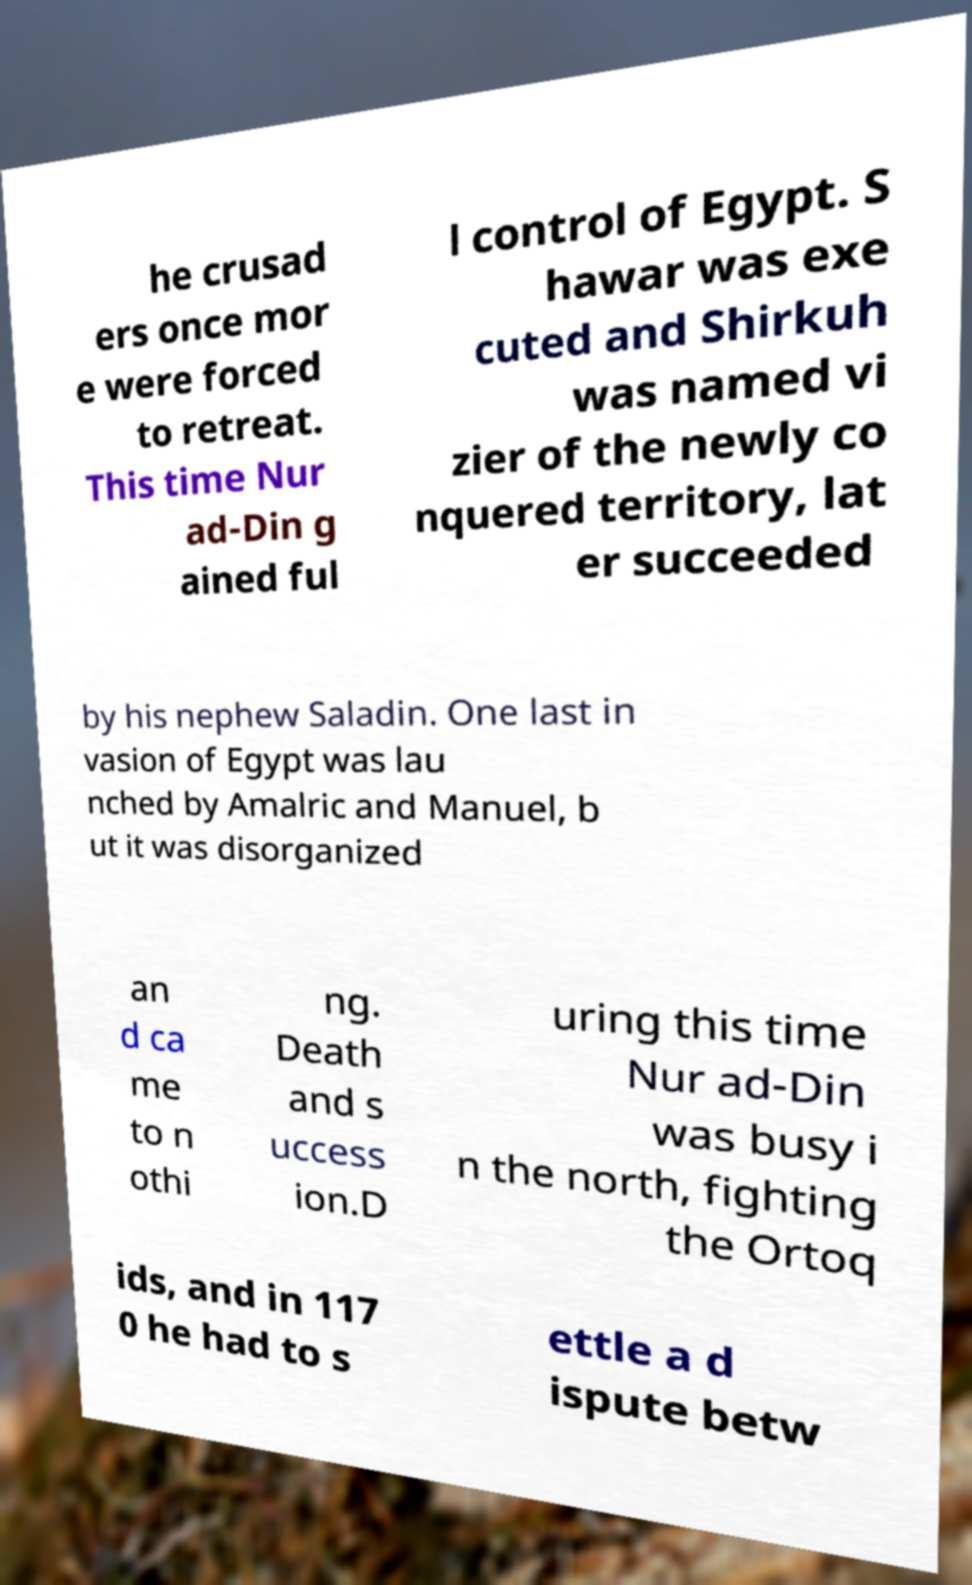For documentation purposes, I need the text within this image transcribed. Could you provide that? he crusad ers once mor e were forced to retreat. This time Nur ad-Din g ained ful l control of Egypt. S hawar was exe cuted and Shirkuh was named vi zier of the newly co nquered territory, lat er succeeded by his nephew Saladin. One last in vasion of Egypt was lau nched by Amalric and Manuel, b ut it was disorganized an d ca me to n othi ng. Death and s uccess ion.D uring this time Nur ad-Din was busy i n the north, fighting the Ortoq ids, and in 117 0 he had to s ettle a d ispute betw 